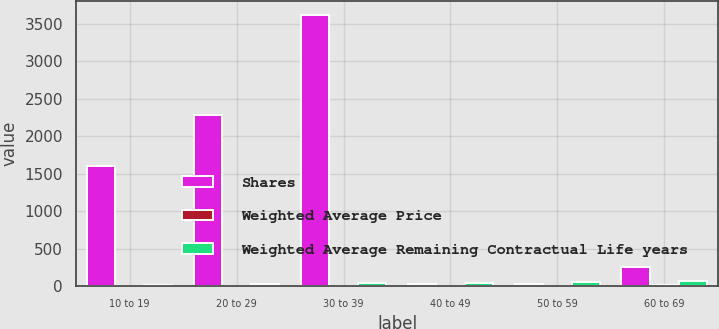<chart> <loc_0><loc_0><loc_500><loc_500><stacked_bar_chart><ecel><fcel>10 to 19<fcel>20 to 29<fcel>30 to 39<fcel>40 to 49<fcel>50 to 59<fcel>60 to 69<nl><fcel>Shares<fcel>1602<fcel>2279<fcel>3622<fcel>31.235<fcel>31.235<fcel>253<nl><fcel>Weighted Average Price<fcel>1.4<fcel>1.9<fcel>6.2<fcel>6.3<fcel>5.7<fcel>8.2<nl><fcel>Weighted Average Remaining Contractual Life years<fcel>15.1<fcel>23.39<fcel>39.08<fcel>42<fcel>54.58<fcel>63.79<nl></chart> 